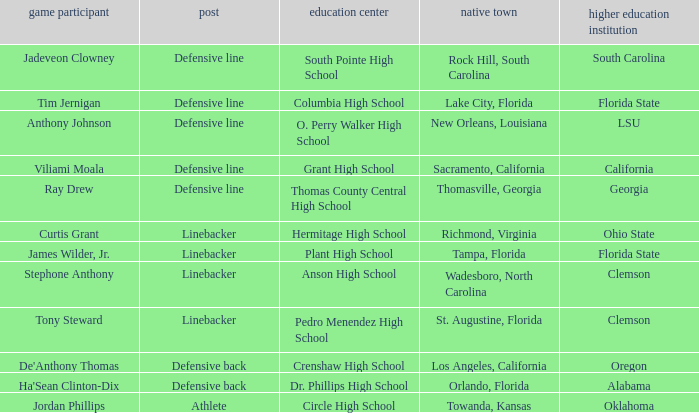Which college is Jordan Phillips playing for? Oklahoma. 